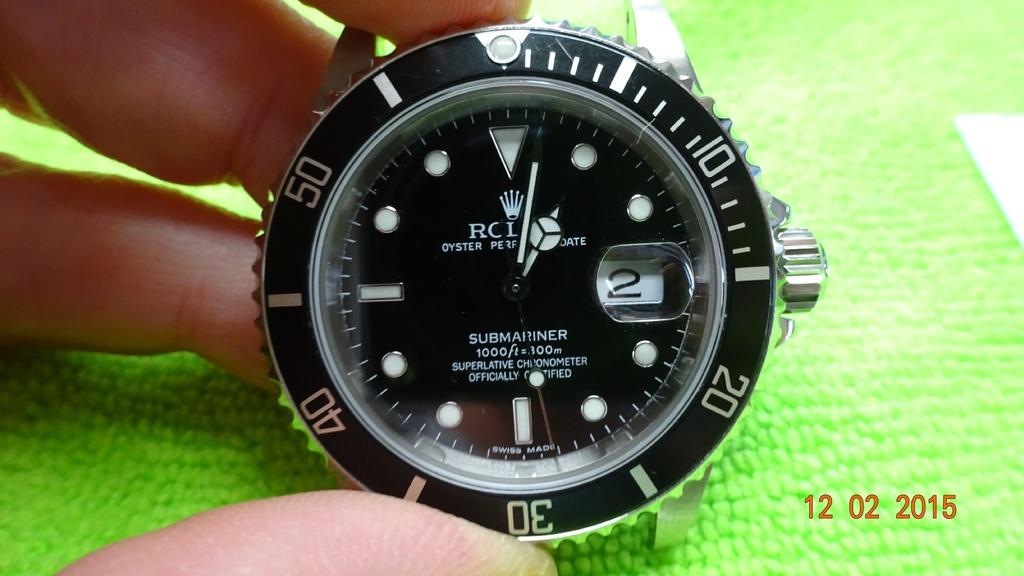What brand is this watch?
Provide a short and direct response. Rolex. What model is this watch?
Offer a terse response. Rolex. 